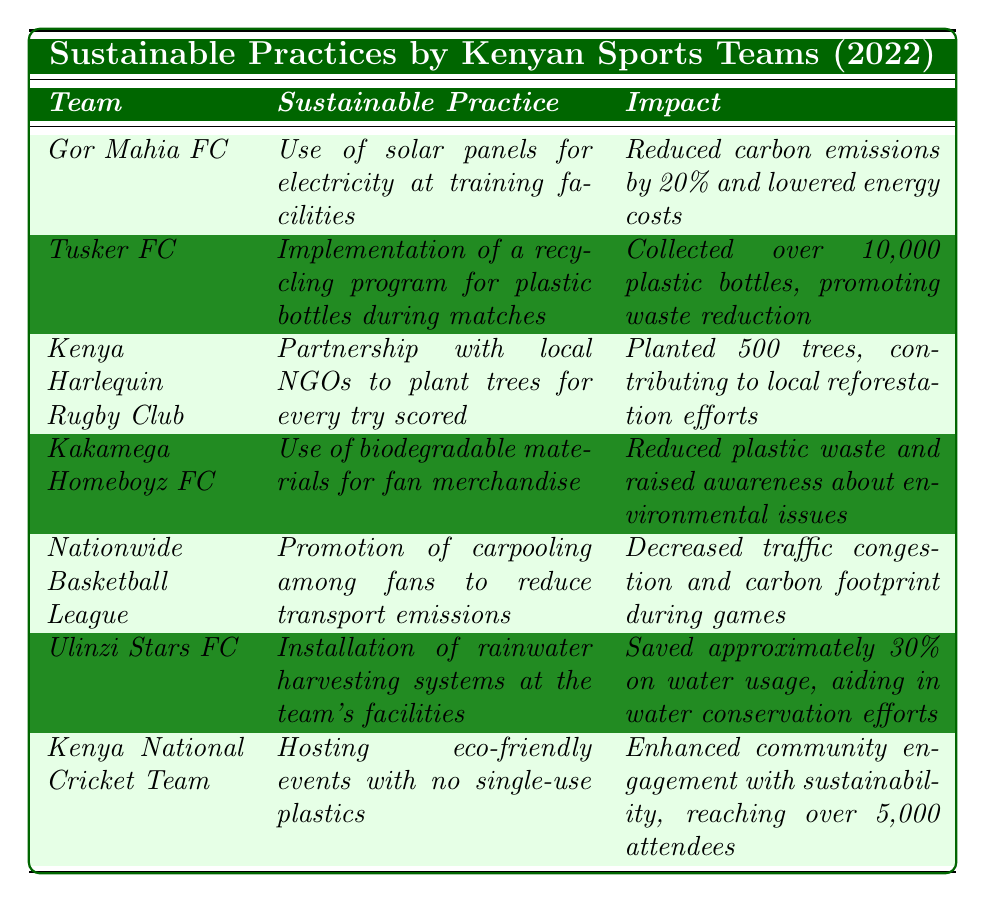What sustainable practice did Gor Mahia FC adopt in 2022? According to the table, Gor Mahia FC adopted the sustainable practice of using solar panels for electricity at their training facilities.
Answer: Use of solar panels for electricity at training facilities How many trees did the Kenya Harlequin Rugby Club plant in 2022? The table lists that the Kenya Harlequin Rugby Club planted 500 trees.
Answer: 500 trees Which team implemented a recycling program during matches? The table reveals that Tusker FC implemented a recycling program for plastic bottles during matches.
Answer: Tusker FC Did Kakamega Homeboyz FC use biodegradable materials for fan merchandise? Yes, the table indicates that Kakamega Homeboyz FC did use biodegradable materials for fan merchandise.
Answer: Yes What impact did Ulinzi Stars FC's rainwater harvesting systems have? Ulinzi Stars FC's installation of rainwater harvesting systems resulted in saving approximately 30% on water usage, aiding in water conservation efforts, as noted in the table.
Answer: Saved approximately 30% on water usage What is the total number of sustainable practices listed in the table? The table includes 7 different sustainable practices adopted by various teams.
Answer: 7 Which team had an impact that included community engagement, and how many attendees were reached? The Kenya National Cricket Team hosted eco-friendly events without single-use plastics and reached over 5,000 attendees, as stated in the table.
Answer: Kenya National Cricket Team, over 5,000 attendees What sustainable practice had the largest reported impact in terms of reduced carbon emissions? Gor Mahia FC reported a 20% reduction in carbon emissions due to the use of solar panels at training facilities, making it the largest reported impact for carbon emissions in the table.
Answer: 20% reduction in carbon emissions Which two teams focused on waste reduction, and what methods did they use? Tusker FC focused on waste reduction through a recycling program for plastic bottles, while Kakamega Homeboyz FC used biodegradable materials for fan merchandise.
Answer: Tusker FC and Kakamega Homeboyz FC If we compare the impact of the recycling program of Tusker FC and the tree planting by Kenya Harlequin Rugby Club, what can we infer about their focus areas? Tusker FC's impact was quantified in terms of the number of plastic bottles collected (over 10,000), while Kenya Harlequin Rugby Club focused on environmental restoration by planting trees (500 trees), indicating they address different aspects of sustainability: waste reduction vs. reforestation.
Answer: Different aspects of sustainability Which teams are involved in community initiatives and what are these initiatives? Kenya Harlequin Rugby Club's initiative involves planting trees for every try scored, and the Kenya National Cricket Team hosts eco-friendly events engaging the community, indicating their focus on environmental sustainability and engagement.
Answer: Kenya Harlequin Rugby Club and Kenya National Cricket Team 